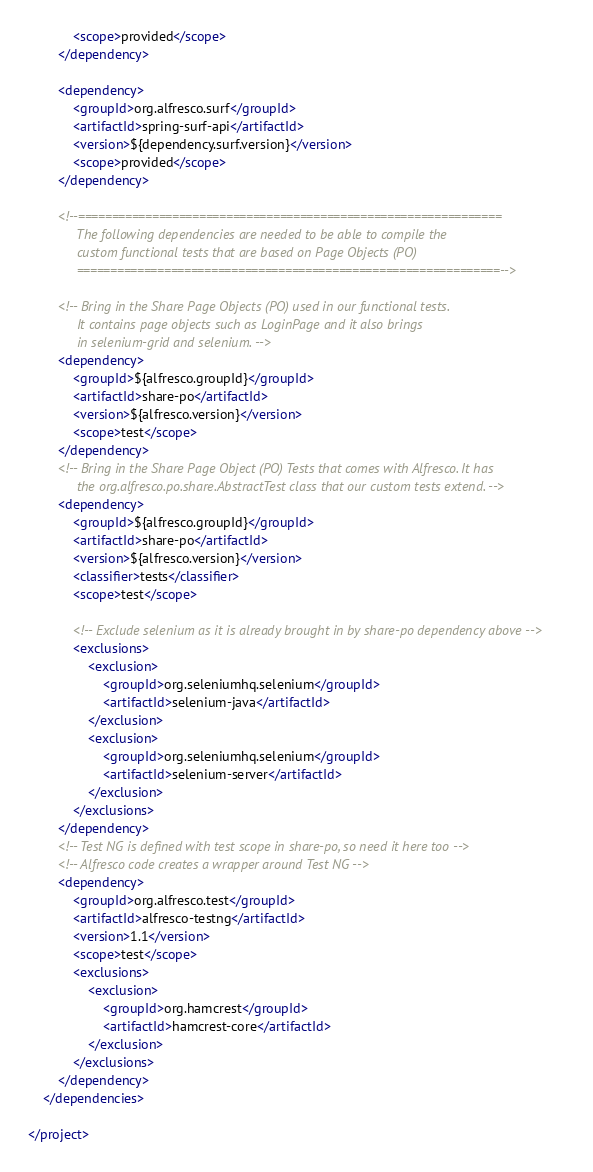Convert code to text. <code><loc_0><loc_0><loc_500><loc_500><_XML_>            <scope>provided</scope>
        </dependency>

        <dependency>
            <groupId>org.alfresco.surf</groupId>
            <artifactId>spring-surf-api</artifactId>
            <version>${dependency.surf.version}</version>
            <scope>provided</scope>
        </dependency>

        <!--===============================================================
             The following dependencies are needed to be able to compile the
             custom functional tests that are based on Page Objects (PO)
             ===============================================================-->

        <!-- Bring in the Share Page Objects (PO) used in our functional tests.
             It contains page objects such as LoginPage and it also brings
             in selenium-grid and selenium. -->
        <dependency>
            <groupId>${alfresco.groupId}</groupId>
            <artifactId>share-po</artifactId>
            <version>${alfresco.version}</version>
            <scope>test</scope>
        </dependency>
        <!-- Bring in the Share Page Object (PO) Tests that comes with Alfresco. It has
             the org.alfresco.po.share.AbstractTest class that our custom tests extend. -->
        <dependency>
            <groupId>${alfresco.groupId}</groupId>
            <artifactId>share-po</artifactId>
            <version>${alfresco.version}</version>
            <classifier>tests</classifier>
            <scope>test</scope>

            <!-- Exclude selenium as it is already brought in by share-po dependency above -->
            <exclusions>
                <exclusion>
                    <groupId>org.seleniumhq.selenium</groupId>
                    <artifactId>selenium-java</artifactId>
                </exclusion>
                <exclusion>
                    <groupId>org.seleniumhq.selenium</groupId>
                    <artifactId>selenium-server</artifactId>
                </exclusion>
            </exclusions>
        </dependency>
        <!-- Test NG is defined with test scope in share-po, so need it here too -->
        <!-- Alfresco code creates a wrapper around Test NG -->
        <dependency>
            <groupId>org.alfresco.test</groupId>
            <artifactId>alfresco-testng</artifactId>
            <version>1.1</version>
            <scope>test</scope>
            <exclusions>
                <exclusion>
                    <groupId>org.hamcrest</groupId>
                    <artifactId>hamcrest-core</artifactId>
                </exclusion>
            </exclusions>
        </dependency>
    </dependencies>

</project>
</code> 